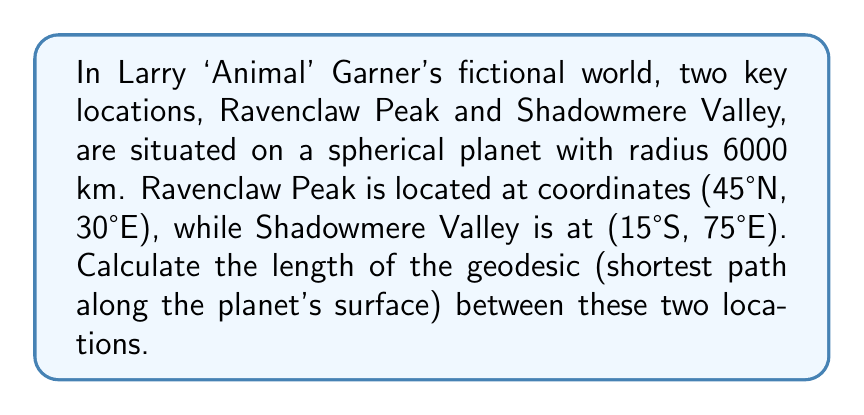Give your solution to this math problem. To solve this problem, we'll use the great circle distance formula, as the geodesic on a sphere is a great circle arc. We'll follow these steps:

1. Convert the coordinates to radians:
   Ravenclaw Peak: $\phi_1 = 45° \cdot \frac{\pi}{180} = \frac{\pi}{4}$, $\lambda_1 = 30° \cdot \frac{\pi}{180} = \frac{\pi}{6}$
   Shadowmere Valley: $\phi_2 = -15° \cdot \frac{\pi}{180} = -\frac{\pi}{12}$, $\lambda_2 = 75° \cdot \frac{\pi}{180} = \frac{5\pi}{12}$

2. Calculate the central angle $\Delta\sigma$ using the Haversine formula:
   $$\Delta\sigma = 2 \arcsin\left(\sqrt{\sin^2\left(\frac{\phi_2 - \phi_1}{2}\right) + \cos\phi_1 \cos\phi_2 \sin^2\left(\frac{\lambda_2 - \lambda_1}{2}\right)}\right)$$

3. Substitute the values:
   $$\Delta\sigma = 2 \arcsin\left(\sqrt{\sin^2\left(\frac{-\frac{\pi}{12} - \frac{\pi}{4}}{2}\right) + \cos\frac{\pi}{4} \cos\left(-\frac{\pi}{12}\right) \sin^2\left(\frac{\frac{5\pi}{12} - \frac{\pi}{6}}{2}\right)}\right)$$

4. Simplify and calculate:
   $$\Delta\sigma \approx 1.0996 \text{ radians}$$

5. Calculate the geodesic distance $d$ using the formula $d = R\Delta\sigma$, where $R$ is the planet's radius:
   $$d = 6000 \text{ km} \cdot 1.0996 \approx 6597.6 \text{ km}$$

Thus, the length of the geodesic between Ravenclaw Peak and Shadowmere Valley is approximately 6597.6 km.
Answer: 6597.6 km 